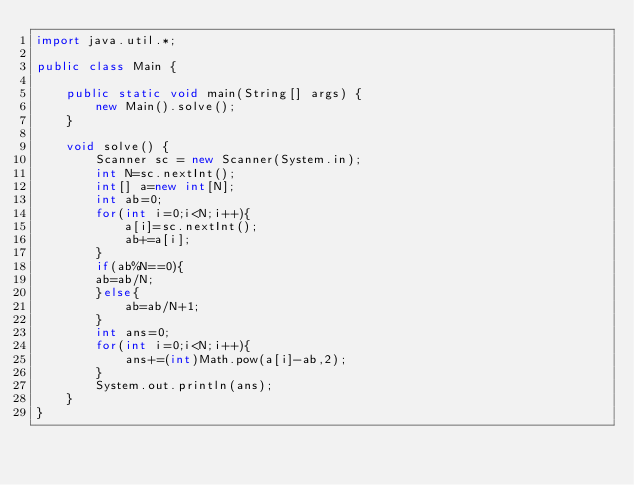Convert code to text. <code><loc_0><loc_0><loc_500><loc_500><_Java_>import java.util.*;

public class Main {

    public static void main(String[] args) {
        new Main().solve();
    }

    void solve() {
        Scanner sc = new Scanner(System.in);
        int N=sc.nextInt();
        int[] a=new int[N];
        int ab=0;
        for(int i=0;i<N;i++){
            a[i]=sc.nextInt();
            ab+=a[i];
        }
        if(ab%N==0){
        ab=ab/N;
        }else{
            ab=ab/N+1;
        }
        int ans=0;
        for(int i=0;i<N;i++){
            ans+=(int)Math.pow(a[i]-ab,2);
        }
        System.out.println(ans);
    }
}
</code> 